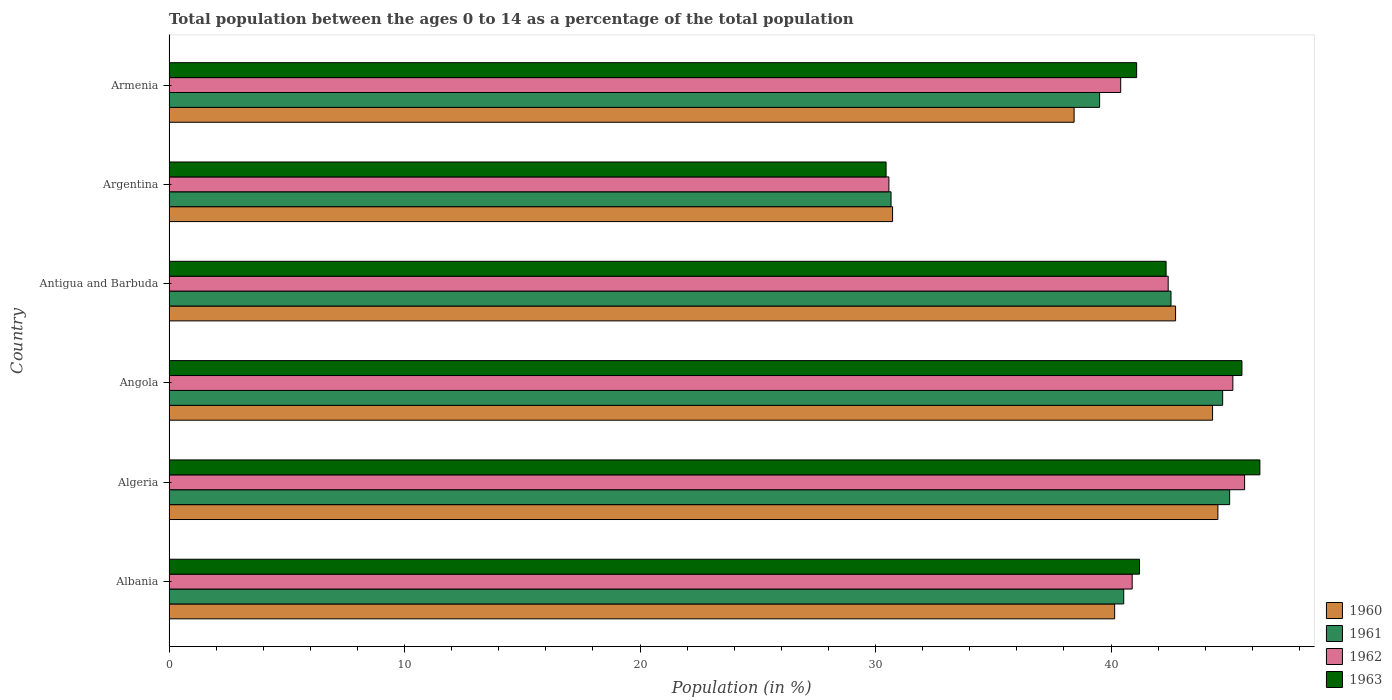How many different coloured bars are there?
Your response must be concise. 4. How many groups of bars are there?
Ensure brevity in your answer.  6. How many bars are there on the 2nd tick from the top?
Make the answer very short. 4. How many bars are there on the 2nd tick from the bottom?
Your response must be concise. 4. What is the label of the 5th group of bars from the top?
Make the answer very short. Algeria. What is the percentage of the population ages 0 to 14 in 1963 in Antigua and Barbuda?
Your answer should be very brief. 42.34. Across all countries, what is the maximum percentage of the population ages 0 to 14 in 1963?
Give a very brief answer. 46.32. Across all countries, what is the minimum percentage of the population ages 0 to 14 in 1960?
Give a very brief answer. 30.73. In which country was the percentage of the population ages 0 to 14 in 1963 maximum?
Provide a short and direct response. Algeria. In which country was the percentage of the population ages 0 to 14 in 1963 minimum?
Provide a succinct answer. Argentina. What is the total percentage of the population ages 0 to 14 in 1961 in the graph?
Offer a terse response. 243.05. What is the difference between the percentage of the population ages 0 to 14 in 1963 in Albania and that in Argentina?
Give a very brief answer. 10.76. What is the difference between the percentage of the population ages 0 to 14 in 1962 in Antigua and Barbuda and the percentage of the population ages 0 to 14 in 1960 in Angola?
Make the answer very short. -1.88. What is the average percentage of the population ages 0 to 14 in 1960 per country?
Provide a short and direct response. 40.15. What is the difference between the percentage of the population ages 0 to 14 in 1962 and percentage of the population ages 0 to 14 in 1961 in Armenia?
Provide a succinct answer. 0.89. What is the ratio of the percentage of the population ages 0 to 14 in 1960 in Antigua and Barbuda to that in Argentina?
Make the answer very short. 1.39. What is the difference between the highest and the second highest percentage of the population ages 0 to 14 in 1960?
Your answer should be very brief. 0.23. What is the difference between the highest and the lowest percentage of the population ages 0 to 14 in 1963?
Your answer should be compact. 15.87. Is it the case that in every country, the sum of the percentage of the population ages 0 to 14 in 1962 and percentage of the population ages 0 to 14 in 1963 is greater than the sum of percentage of the population ages 0 to 14 in 1961 and percentage of the population ages 0 to 14 in 1960?
Offer a terse response. No. What does the 1st bar from the bottom in Armenia represents?
Offer a very short reply. 1960. Is it the case that in every country, the sum of the percentage of the population ages 0 to 14 in 1960 and percentage of the population ages 0 to 14 in 1961 is greater than the percentage of the population ages 0 to 14 in 1963?
Provide a succinct answer. Yes. How many bars are there?
Your answer should be compact. 24. Are all the bars in the graph horizontal?
Your answer should be compact. Yes. What is the difference between two consecutive major ticks on the X-axis?
Provide a succinct answer. 10. Are the values on the major ticks of X-axis written in scientific E-notation?
Offer a very short reply. No. How are the legend labels stacked?
Give a very brief answer. Vertical. What is the title of the graph?
Keep it short and to the point. Total population between the ages 0 to 14 as a percentage of the total population. What is the label or title of the X-axis?
Keep it short and to the point. Population (in %). What is the Population (in %) in 1960 in Albania?
Keep it short and to the point. 40.15. What is the Population (in %) in 1961 in Albania?
Your answer should be very brief. 40.54. What is the Population (in %) in 1962 in Albania?
Your answer should be compact. 40.9. What is the Population (in %) of 1963 in Albania?
Give a very brief answer. 41.21. What is the Population (in %) of 1960 in Algeria?
Your answer should be compact. 44.54. What is the Population (in %) in 1961 in Algeria?
Your answer should be very brief. 45.04. What is the Population (in %) in 1962 in Algeria?
Make the answer very short. 45.67. What is the Population (in %) in 1963 in Algeria?
Make the answer very short. 46.32. What is the Population (in %) of 1960 in Angola?
Your answer should be compact. 44.31. What is the Population (in %) of 1961 in Angola?
Offer a very short reply. 44.74. What is the Population (in %) in 1962 in Angola?
Ensure brevity in your answer.  45.17. What is the Population (in %) of 1963 in Angola?
Offer a very short reply. 45.56. What is the Population (in %) of 1960 in Antigua and Barbuda?
Your answer should be compact. 42.74. What is the Population (in %) of 1961 in Antigua and Barbuda?
Provide a succinct answer. 42.55. What is the Population (in %) of 1962 in Antigua and Barbuda?
Your answer should be very brief. 42.43. What is the Population (in %) in 1963 in Antigua and Barbuda?
Make the answer very short. 42.34. What is the Population (in %) in 1960 in Argentina?
Provide a succinct answer. 30.73. What is the Population (in %) in 1961 in Argentina?
Ensure brevity in your answer.  30.66. What is the Population (in %) of 1962 in Argentina?
Provide a short and direct response. 30.57. What is the Population (in %) of 1963 in Argentina?
Give a very brief answer. 30.45. What is the Population (in %) of 1960 in Armenia?
Provide a succinct answer. 38.43. What is the Population (in %) in 1961 in Armenia?
Provide a succinct answer. 39.52. What is the Population (in %) in 1962 in Armenia?
Make the answer very short. 40.41. What is the Population (in %) in 1963 in Armenia?
Ensure brevity in your answer.  41.09. Across all countries, what is the maximum Population (in %) in 1960?
Offer a terse response. 44.54. Across all countries, what is the maximum Population (in %) of 1961?
Give a very brief answer. 45.04. Across all countries, what is the maximum Population (in %) of 1962?
Ensure brevity in your answer.  45.67. Across all countries, what is the maximum Population (in %) in 1963?
Provide a succinct answer. 46.32. Across all countries, what is the minimum Population (in %) of 1960?
Provide a succinct answer. 30.73. Across all countries, what is the minimum Population (in %) of 1961?
Provide a short and direct response. 30.66. Across all countries, what is the minimum Population (in %) in 1962?
Keep it short and to the point. 30.57. Across all countries, what is the minimum Population (in %) of 1963?
Give a very brief answer. 30.45. What is the total Population (in %) in 1960 in the graph?
Make the answer very short. 240.91. What is the total Population (in %) in 1961 in the graph?
Ensure brevity in your answer.  243.05. What is the total Population (in %) of 1962 in the graph?
Give a very brief answer. 245.16. What is the total Population (in %) in 1963 in the graph?
Give a very brief answer. 246.97. What is the difference between the Population (in %) of 1960 in Albania and that in Algeria?
Your response must be concise. -4.38. What is the difference between the Population (in %) of 1961 in Albania and that in Algeria?
Ensure brevity in your answer.  -4.5. What is the difference between the Population (in %) in 1962 in Albania and that in Algeria?
Ensure brevity in your answer.  -4.77. What is the difference between the Population (in %) of 1963 in Albania and that in Algeria?
Provide a succinct answer. -5.11. What is the difference between the Population (in %) of 1960 in Albania and that in Angola?
Ensure brevity in your answer.  -4.16. What is the difference between the Population (in %) of 1961 in Albania and that in Angola?
Give a very brief answer. -4.2. What is the difference between the Population (in %) of 1962 in Albania and that in Angola?
Offer a very short reply. -4.28. What is the difference between the Population (in %) in 1963 in Albania and that in Angola?
Provide a succinct answer. -4.35. What is the difference between the Population (in %) of 1960 in Albania and that in Antigua and Barbuda?
Keep it short and to the point. -2.59. What is the difference between the Population (in %) in 1961 in Albania and that in Antigua and Barbuda?
Provide a short and direct response. -2.01. What is the difference between the Population (in %) in 1962 in Albania and that in Antigua and Barbuda?
Provide a short and direct response. -1.53. What is the difference between the Population (in %) of 1963 in Albania and that in Antigua and Barbuda?
Make the answer very short. -1.13. What is the difference between the Population (in %) in 1960 in Albania and that in Argentina?
Your answer should be very brief. 9.43. What is the difference between the Population (in %) of 1961 in Albania and that in Argentina?
Provide a succinct answer. 9.88. What is the difference between the Population (in %) of 1962 in Albania and that in Argentina?
Give a very brief answer. 10.33. What is the difference between the Population (in %) in 1963 in Albania and that in Argentina?
Ensure brevity in your answer.  10.76. What is the difference between the Population (in %) in 1960 in Albania and that in Armenia?
Your response must be concise. 1.72. What is the difference between the Population (in %) in 1961 in Albania and that in Armenia?
Provide a short and direct response. 1.02. What is the difference between the Population (in %) in 1962 in Albania and that in Armenia?
Your answer should be compact. 0.49. What is the difference between the Population (in %) in 1963 in Albania and that in Armenia?
Make the answer very short. 0.12. What is the difference between the Population (in %) in 1960 in Algeria and that in Angola?
Give a very brief answer. 0.23. What is the difference between the Population (in %) in 1961 in Algeria and that in Angola?
Your response must be concise. 0.3. What is the difference between the Population (in %) in 1962 in Algeria and that in Angola?
Your response must be concise. 0.5. What is the difference between the Population (in %) in 1963 in Algeria and that in Angola?
Provide a short and direct response. 0.76. What is the difference between the Population (in %) in 1960 in Algeria and that in Antigua and Barbuda?
Keep it short and to the point. 1.8. What is the difference between the Population (in %) of 1961 in Algeria and that in Antigua and Barbuda?
Your answer should be very brief. 2.49. What is the difference between the Population (in %) in 1962 in Algeria and that in Antigua and Barbuda?
Provide a short and direct response. 3.25. What is the difference between the Population (in %) of 1963 in Algeria and that in Antigua and Barbuda?
Offer a very short reply. 3.98. What is the difference between the Population (in %) in 1960 in Algeria and that in Argentina?
Keep it short and to the point. 13.81. What is the difference between the Population (in %) of 1961 in Algeria and that in Argentina?
Make the answer very short. 14.38. What is the difference between the Population (in %) in 1962 in Algeria and that in Argentina?
Make the answer very short. 15.1. What is the difference between the Population (in %) of 1963 in Algeria and that in Argentina?
Your answer should be very brief. 15.87. What is the difference between the Population (in %) of 1960 in Algeria and that in Armenia?
Your answer should be very brief. 6.11. What is the difference between the Population (in %) in 1961 in Algeria and that in Armenia?
Provide a short and direct response. 5.52. What is the difference between the Population (in %) of 1962 in Algeria and that in Armenia?
Offer a very short reply. 5.26. What is the difference between the Population (in %) in 1963 in Algeria and that in Armenia?
Your answer should be very brief. 5.23. What is the difference between the Population (in %) of 1960 in Angola and that in Antigua and Barbuda?
Ensure brevity in your answer.  1.57. What is the difference between the Population (in %) of 1961 in Angola and that in Antigua and Barbuda?
Offer a very short reply. 2.19. What is the difference between the Population (in %) of 1962 in Angola and that in Antigua and Barbuda?
Provide a short and direct response. 2.75. What is the difference between the Population (in %) in 1963 in Angola and that in Antigua and Barbuda?
Offer a very short reply. 3.22. What is the difference between the Population (in %) of 1960 in Angola and that in Argentina?
Offer a terse response. 13.59. What is the difference between the Population (in %) of 1961 in Angola and that in Argentina?
Your answer should be compact. 14.08. What is the difference between the Population (in %) in 1962 in Angola and that in Argentina?
Make the answer very short. 14.61. What is the difference between the Population (in %) of 1963 in Angola and that in Argentina?
Provide a succinct answer. 15.11. What is the difference between the Population (in %) in 1960 in Angola and that in Armenia?
Ensure brevity in your answer.  5.88. What is the difference between the Population (in %) in 1961 in Angola and that in Armenia?
Your response must be concise. 5.22. What is the difference between the Population (in %) of 1962 in Angola and that in Armenia?
Make the answer very short. 4.76. What is the difference between the Population (in %) in 1963 in Angola and that in Armenia?
Give a very brief answer. 4.47. What is the difference between the Population (in %) in 1960 in Antigua and Barbuda and that in Argentina?
Give a very brief answer. 12.02. What is the difference between the Population (in %) of 1961 in Antigua and Barbuda and that in Argentina?
Your answer should be very brief. 11.89. What is the difference between the Population (in %) of 1962 in Antigua and Barbuda and that in Argentina?
Ensure brevity in your answer.  11.86. What is the difference between the Population (in %) in 1963 in Antigua and Barbuda and that in Argentina?
Your response must be concise. 11.89. What is the difference between the Population (in %) of 1960 in Antigua and Barbuda and that in Armenia?
Provide a succinct answer. 4.31. What is the difference between the Population (in %) of 1961 in Antigua and Barbuda and that in Armenia?
Provide a short and direct response. 3.03. What is the difference between the Population (in %) of 1962 in Antigua and Barbuda and that in Armenia?
Keep it short and to the point. 2.02. What is the difference between the Population (in %) of 1963 in Antigua and Barbuda and that in Armenia?
Your response must be concise. 1.25. What is the difference between the Population (in %) in 1960 in Argentina and that in Armenia?
Provide a succinct answer. -7.71. What is the difference between the Population (in %) in 1961 in Argentina and that in Armenia?
Offer a terse response. -8.86. What is the difference between the Population (in %) of 1962 in Argentina and that in Armenia?
Offer a very short reply. -9.84. What is the difference between the Population (in %) in 1963 in Argentina and that in Armenia?
Make the answer very short. -10.64. What is the difference between the Population (in %) in 1960 in Albania and the Population (in %) in 1961 in Algeria?
Ensure brevity in your answer.  -4.88. What is the difference between the Population (in %) of 1960 in Albania and the Population (in %) of 1962 in Algeria?
Your response must be concise. -5.52. What is the difference between the Population (in %) in 1960 in Albania and the Population (in %) in 1963 in Algeria?
Your answer should be very brief. -6.17. What is the difference between the Population (in %) in 1961 in Albania and the Population (in %) in 1962 in Algeria?
Offer a terse response. -5.13. What is the difference between the Population (in %) in 1961 in Albania and the Population (in %) in 1963 in Algeria?
Provide a short and direct response. -5.78. What is the difference between the Population (in %) in 1962 in Albania and the Population (in %) in 1963 in Algeria?
Offer a very short reply. -5.42. What is the difference between the Population (in %) of 1960 in Albania and the Population (in %) of 1961 in Angola?
Ensure brevity in your answer.  -4.59. What is the difference between the Population (in %) of 1960 in Albania and the Population (in %) of 1962 in Angola?
Offer a very short reply. -5.02. What is the difference between the Population (in %) in 1960 in Albania and the Population (in %) in 1963 in Angola?
Ensure brevity in your answer.  -5.41. What is the difference between the Population (in %) in 1961 in Albania and the Population (in %) in 1962 in Angola?
Keep it short and to the point. -4.63. What is the difference between the Population (in %) in 1961 in Albania and the Population (in %) in 1963 in Angola?
Keep it short and to the point. -5.02. What is the difference between the Population (in %) in 1962 in Albania and the Population (in %) in 1963 in Angola?
Offer a very short reply. -4.66. What is the difference between the Population (in %) in 1960 in Albania and the Population (in %) in 1961 in Antigua and Barbuda?
Offer a terse response. -2.39. What is the difference between the Population (in %) of 1960 in Albania and the Population (in %) of 1962 in Antigua and Barbuda?
Your answer should be compact. -2.27. What is the difference between the Population (in %) in 1960 in Albania and the Population (in %) in 1963 in Antigua and Barbuda?
Provide a short and direct response. -2.18. What is the difference between the Population (in %) in 1961 in Albania and the Population (in %) in 1962 in Antigua and Barbuda?
Your response must be concise. -1.89. What is the difference between the Population (in %) in 1961 in Albania and the Population (in %) in 1963 in Antigua and Barbuda?
Provide a short and direct response. -1.8. What is the difference between the Population (in %) of 1962 in Albania and the Population (in %) of 1963 in Antigua and Barbuda?
Give a very brief answer. -1.44. What is the difference between the Population (in %) of 1960 in Albania and the Population (in %) of 1961 in Argentina?
Provide a short and direct response. 9.49. What is the difference between the Population (in %) of 1960 in Albania and the Population (in %) of 1962 in Argentina?
Ensure brevity in your answer.  9.59. What is the difference between the Population (in %) in 1960 in Albania and the Population (in %) in 1963 in Argentina?
Offer a terse response. 9.71. What is the difference between the Population (in %) of 1961 in Albania and the Population (in %) of 1962 in Argentina?
Your response must be concise. 9.97. What is the difference between the Population (in %) of 1961 in Albania and the Population (in %) of 1963 in Argentina?
Give a very brief answer. 10.09. What is the difference between the Population (in %) in 1962 in Albania and the Population (in %) in 1963 in Argentina?
Provide a succinct answer. 10.45. What is the difference between the Population (in %) of 1960 in Albania and the Population (in %) of 1961 in Armenia?
Provide a short and direct response. 0.64. What is the difference between the Population (in %) in 1960 in Albania and the Population (in %) in 1962 in Armenia?
Provide a succinct answer. -0.26. What is the difference between the Population (in %) of 1960 in Albania and the Population (in %) of 1963 in Armenia?
Make the answer very short. -0.93. What is the difference between the Population (in %) in 1961 in Albania and the Population (in %) in 1962 in Armenia?
Your answer should be very brief. 0.13. What is the difference between the Population (in %) of 1961 in Albania and the Population (in %) of 1963 in Armenia?
Your answer should be compact. -0.55. What is the difference between the Population (in %) of 1962 in Albania and the Population (in %) of 1963 in Armenia?
Your answer should be compact. -0.19. What is the difference between the Population (in %) of 1960 in Algeria and the Population (in %) of 1961 in Angola?
Your answer should be compact. -0.2. What is the difference between the Population (in %) of 1960 in Algeria and the Population (in %) of 1962 in Angola?
Ensure brevity in your answer.  -0.64. What is the difference between the Population (in %) of 1960 in Algeria and the Population (in %) of 1963 in Angola?
Offer a very short reply. -1.02. What is the difference between the Population (in %) in 1961 in Algeria and the Population (in %) in 1962 in Angola?
Your answer should be very brief. -0.14. What is the difference between the Population (in %) of 1961 in Algeria and the Population (in %) of 1963 in Angola?
Your answer should be very brief. -0.52. What is the difference between the Population (in %) in 1962 in Algeria and the Population (in %) in 1963 in Angola?
Provide a succinct answer. 0.11. What is the difference between the Population (in %) of 1960 in Algeria and the Population (in %) of 1961 in Antigua and Barbuda?
Provide a succinct answer. 1.99. What is the difference between the Population (in %) of 1960 in Algeria and the Population (in %) of 1962 in Antigua and Barbuda?
Offer a very short reply. 2.11. What is the difference between the Population (in %) of 1960 in Algeria and the Population (in %) of 1963 in Antigua and Barbuda?
Offer a very short reply. 2.2. What is the difference between the Population (in %) in 1961 in Algeria and the Population (in %) in 1962 in Antigua and Barbuda?
Make the answer very short. 2.61. What is the difference between the Population (in %) in 1961 in Algeria and the Population (in %) in 1963 in Antigua and Barbuda?
Your answer should be very brief. 2.7. What is the difference between the Population (in %) in 1962 in Algeria and the Population (in %) in 1963 in Antigua and Barbuda?
Provide a short and direct response. 3.33. What is the difference between the Population (in %) in 1960 in Algeria and the Population (in %) in 1961 in Argentina?
Give a very brief answer. 13.88. What is the difference between the Population (in %) of 1960 in Algeria and the Population (in %) of 1962 in Argentina?
Offer a very short reply. 13.97. What is the difference between the Population (in %) of 1960 in Algeria and the Population (in %) of 1963 in Argentina?
Provide a succinct answer. 14.09. What is the difference between the Population (in %) in 1961 in Algeria and the Population (in %) in 1962 in Argentina?
Your answer should be very brief. 14.47. What is the difference between the Population (in %) in 1961 in Algeria and the Population (in %) in 1963 in Argentina?
Your answer should be compact. 14.59. What is the difference between the Population (in %) of 1962 in Algeria and the Population (in %) of 1963 in Argentina?
Make the answer very short. 15.22. What is the difference between the Population (in %) in 1960 in Algeria and the Population (in %) in 1961 in Armenia?
Your answer should be very brief. 5.02. What is the difference between the Population (in %) of 1960 in Algeria and the Population (in %) of 1962 in Armenia?
Make the answer very short. 4.13. What is the difference between the Population (in %) in 1960 in Algeria and the Population (in %) in 1963 in Armenia?
Offer a very short reply. 3.45. What is the difference between the Population (in %) of 1961 in Algeria and the Population (in %) of 1962 in Armenia?
Offer a very short reply. 4.63. What is the difference between the Population (in %) of 1961 in Algeria and the Population (in %) of 1963 in Armenia?
Provide a succinct answer. 3.95. What is the difference between the Population (in %) in 1962 in Algeria and the Population (in %) in 1963 in Armenia?
Make the answer very short. 4.58. What is the difference between the Population (in %) of 1960 in Angola and the Population (in %) of 1961 in Antigua and Barbuda?
Make the answer very short. 1.76. What is the difference between the Population (in %) of 1960 in Angola and the Population (in %) of 1962 in Antigua and Barbuda?
Your answer should be very brief. 1.88. What is the difference between the Population (in %) in 1960 in Angola and the Population (in %) in 1963 in Antigua and Barbuda?
Ensure brevity in your answer.  1.97. What is the difference between the Population (in %) of 1961 in Angola and the Population (in %) of 1962 in Antigua and Barbuda?
Provide a succinct answer. 2.31. What is the difference between the Population (in %) of 1961 in Angola and the Population (in %) of 1963 in Antigua and Barbuda?
Give a very brief answer. 2.4. What is the difference between the Population (in %) in 1962 in Angola and the Population (in %) in 1963 in Antigua and Barbuda?
Your response must be concise. 2.84. What is the difference between the Population (in %) in 1960 in Angola and the Population (in %) in 1961 in Argentina?
Make the answer very short. 13.65. What is the difference between the Population (in %) in 1960 in Angola and the Population (in %) in 1962 in Argentina?
Offer a terse response. 13.74. What is the difference between the Population (in %) in 1960 in Angola and the Population (in %) in 1963 in Argentina?
Keep it short and to the point. 13.86. What is the difference between the Population (in %) in 1961 in Angola and the Population (in %) in 1962 in Argentina?
Provide a short and direct response. 14.17. What is the difference between the Population (in %) in 1961 in Angola and the Population (in %) in 1963 in Argentina?
Your answer should be compact. 14.29. What is the difference between the Population (in %) in 1962 in Angola and the Population (in %) in 1963 in Argentina?
Provide a short and direct response. 14.73. What is the difference between the Population (in %) in 1960 in Angola and the Population (in %) in 1961 in Armenia?
Your response must be concise. 4.8. What is the difference between the Population (in %) in 1960 in Angola and the Population (in %) in 1962 in Armenia?
Ensure brevity in your answer.  3.9. What is the difference between the Population (in %) in 1960 in Angola and the Population (in %) in 1963 in Armenia?
Offer a very short reply. 3.22. What is the difference between the Population (in %) in 1961 in Angola and the Population (in %) in 1962 in Armenia?
Ensure brevity in your answer.  4.33. What is the difference between the Population (in %) in 1961 in Angola and the Population (in %) in 1963 in Armenia?
Your answer should be very brief. 3.65. What is the difference between the Population (in %) of 1962 in Angola and the Population (in %) of 1963 in Armenia?
Your answer should be very brief. 4.09. What is the difference between the Population (in %) in 1960 in Antigua and Barbuda and the Population (in %) in 1961 in Argentina?
Offer a very short reply. 12.08. What is the difference between the Population (in %) of 1960 in Antigua and Barbuda and the Population (in %) of 1962 in Argentina?
Make the answer very short. 12.17. What is the difference between the Population (in %) in 1960 in Antigua and Barbuda and the Population (in %) in 1963 in Argentina?
Your answer should be very brief. 12.29. What is the difference between the Population (in %) in 1961 in Antigua and Barbuda and the Population (in %) in 1962 in Argentina?
Your response must be concise. 11.98. What is the difference between the Population (in %) of 1961 in Antigua and Barbuda and the Population (in %) of 1963 in Argentina?
Make the answer very short. 12.1. What is the difference between the Population (in %) of 1962 in Antigua and Barbuda and the Population (in %) of 1963 in Argentina?
Offer a terse response. 11.98. What is the difference between the Population (in %) of 1960 in Antigua and Barbuda and the Population (in %) of 1961 in Armenia?
Your answer should be compact. 3.23. What is the difference between the Population (in %) of 1960 in Antigua and Barbuda and the Population (in %) of 1962 in Armenia?
Offer a terse response. 2.33. What is the difference between the Population (in %) in 1960 in Antigua and Barbuda and the Population (in %) in 1963 in Armenia?
Make the answer very short. 1.65. What is the difference between the Population (in %) in 1961 in Antigua and Barbuda and the Population (in %) in 1962 in Armenia?
Give a very brief answer. 2.14. What is the difference between the Population (in %) of 1961 in Antigua and Barbuda and the Population (in %) of 1963 in Armenia?
Provide a succinct answer. 1.46. What is the difference between the Population (in %) in 1962 in Antigua and Barbuda and the Population (in %) in 1963 in Armenia?
Offer a very short reply. 1.34. What is the difference between the Population (in %) in 1960 in Argentina and the Population (in %) in 1961 in Armenia?
Provide a short and direct response. -8.79. What is the difference between the Population (in %) in 1960 in Argentina and the Population (in %) in 1962 in Armenia?
Your answer should be compact. -9.69. What is the difference between the Population (in %) of 1960 in Argentina and the Population (in %) of 1963 in Armenia?
Keep it short and to the point. -10.36. What is the difference between the Population (in %) of 1961 in Argentina and the Population (in %) of 1962 in Armenia?
Provide a succinct answer. -9.75. What is the difference between the Population (in %) in 1961 in Argentina and the Population (in %) in 1963 in Armenia?
Make the answer very short. -10.43. What is the difference between the Population (in %) in 1962 in Argentina and the Population (in %) in 1963 in Armenia?
Provide a short and direct response. -10.52. What is the average Population (in %) in 1960 per country?
Make the answer very short. 40.15. What is the average Population (in %) of 1961 per country?
Offer a terse response. 40.51. What is the average Population (in %) in 1962 per country?
Give a very brief answer. 40.86. What is the average Population (in %) in 1963 per country?
Provide a short and direct response. 41.16. What is the difference between the Population (in %) in 1960 and Population (in %) in 1961 in Albania?
Provide a succinct answer. -0.39. What is the difference between the Population (in %) in 1960 and Population (in %) in 1962 in Albania?
Make the answer very short. -0.74. What is the difference between the Population (in %) in 1960 and Population (in %) in 1963 in Albania?
Provide a succinct answer. -1.06. What is the difference between the Population (in %) of 1961 and Population (in %) of 1962 in Albania?
Ensure brevity in your answer.  -0.36. What is the difference between the Population (in %) in 1961 and Population (in %) in 1963 in Albania?
Provide a succinct answer. -0.67. What is the difference between the Population (in %) in 1962 and Population (in %) in 1963 in Albania?
Keep it short and to the point. -0.31. What is the difference between the Population (in %) in 1960 and Population (in %) in 1961 in Algeria?
Offer a very short reply. -0.5. What is the difference between the Population (in %) of 1960 and Population (in %) of 1962 in Algeria?
Provide a short and direct response. -1.13. What is the difference between the Population (in %) of 1960 and Population (in %) of 1963 in Algeria?
Ensure brevity in your answer.  -1.78. What is the difference between the Population (in %) in 1961 and Population (in %) in 1962 in Algeria?
Provide a succinct answer. -0.64. What is the difference between the Population (in %) of 1961 and Population (in %) of 1963 in Algeria?
Your answer should be very brief. -1.28. What is the difference between the Population (in %) of 1962 and Population (in %) of 1963 in Algeria?
Ensure brevity in your answer.  -0.65. What is the difference between the Population (in %) of 1960 and Population (in %) of 1961 in Angola?
Your answer should be compact. -0.43. What is the difference between the Population (in %) in 1960 and Population (in %) in 1962 in Angola?
Ensure brevity in your answer.  -0.86. What is the difference between the Population (in %) in 1960 and Population (in %) in 1963 in Angola?
Make the answer very short. -1.25. What is the difference between the Population (in %) in 1961 and Population (in %) in 1962 in Angola?
Keep it short and to the point. -0.43. What is the difference between the Population (in %) in 1961 and Population (in %) in 1963 in Angola?
Provide a succinct answer. -0.82. What is the difference between the Population (in %) in 1962 and Population (in %) in 1963 in Angola?
Your response must be concise. -0.39. What is the difference between the Population (in %) in 1960 and Population (in %) in 1961 in Antigua and Barbuda?
Your answer should be very brief. 0.19. What is the difference between the Population (in %) in 1960 and Population (in %) in 1962 in Antigua and Barbuda?
Provide a succinct answer. 0.31. What is the difference between the Population (in %) in 1960 and Population (in %) in 1963 in Antigua and Barbuda?
Offer a very short reply. 0.4. What is the difference between the Population (in %) in 1961 and Population (in %) in 1962 in Antigua and Barbuda?
Your answer should be very brief. 0.12. What is the difference between the Population (in %) in 1961 and Population (in %) in 1963 in Antigua and Barbuda?
Provide a succinct answer. 0.21. What is the difference between the Population (in %) in 1962 and Population (in %) in 1963 in Antigua and Barbuda?
Offer a terse response. 0.09. What is the difference between the Population (in %) in 1960 and Population (in %) in 1961 in Argentina?
Provide a short and direct response. 0.07. What is the difference between the Population (in %) in 1960 and Population (in %) in 1962 in Argentina?
Provide a succinct answer. 0.16. What is the difference between the Population (in %) of 1960 and Population (in %) of 1963 in Argentina?
Ensure brevity in your answer.  0.28. What is the difference between the Population (in %) of 1961 and Population (in %) of 1962 in Argentina?
Provide a succinct answer. 0.09. What is the difference between the Population (in %) of 1961 and Population (in %) of 1963 in Argentina?
Offer a very short reply. 0.21. What is the difference between the Population (in %) in 1962 and Population (in %) in 1963 in Argentina?
Provide a short and direct response. 0.12. What is the difference between the Population (in %) of 1960 and Population (in %) of 1961 in Armenia?
Your answer should be very brief. -1.08. What is the difference between the Population (in %) of 1960 and Population (in %) of 1962 in Armenia?
Your response must be concise. -1.98. What is the difference between the Population (in %) of 1960 and Population (in %) of 1963 in Armenia?
Your answer should be compact. -2.66. What is the difference between the Population (in %) in 1961 and Population (in %) in 1962 in Armenia?
Your answer should be very brief. -0.89. What is the difference between the Population (in %) in 1961 and Population (in %) in 1963 in Armenia?
Offer a very short reply. -1.57. What is the difference between the Population (in %) of 1962 and Population (in %) of 1963 in Armenia?
Give a very brief answer. -0.68. What is the ratio of the Population (in %) in 1960 in Albania to that in Algeria?
Ensure brevity in your answer.  0.9. What is the ratio of the Population (in %) of 1961 in Albania to that in Algeria?
Your response must be concise. 0.9. What is the ratio of the Population (in %) in 1962 in Albania to that in Algeria?
Provide a short and direct response. 0.9. What is the ratio of the Population (in %) of 1963 in Albania to that in Algeria?
Give a very brief answer. 0.89. What is the ratio of the Population (in %) in 1960 in Albania to that in Angola?
Make the answer very short. 0.91. What is the ratio of the Population (in %) of 1961 in Albania to that in Angola?
Your response must be concise. 0.91. What is the ratio of the Population (in %) of 1962 in Albania to that in Angola?
Provide a short and direct response. 0.91. What is the ratio of the Population (in %) of 1963 in Albania to that in Angola?
Give a very brief answer. 0.9. What is the ratio of the Population (in %) of 1960 in Albania to that in Antigua and Barbuda?
Your answer should be compact. 0.94. What is the ratio of the Population (in %) in 1961 in Albania to that in Antigua and Barbuda?
Provide a short and direct response. 0.95. What is the ratio of the Population (in %) in 1962 in Albania to that in Antigua and Barbuda?
Offer a terse response. 0.96. What is the ratio of the Population (in %) of 1963 in Albania to that in Antigua and Barbuda?
Give a very brief answer. 0.97. What is the ratio of the Population (in %) in 1960 in Albania to that in Argentina?
Offer a very short reply. 1.31. What is the ratio of the Population (in %) of 1961 in Albania to that in Argentina?
Your response must be concise. 1.32. What is the ratio of the Population (in %) of 1962 in Albania to that in Argentina?
Keep it short and to the point. 1.34. What is the ratio of the Population (in %) in 1963 in Albania to that in Argentina?
Offer a very short reply. 1.35. What is the ratio of the Population (in %) of 1960 in Albania to that in Armenia?
Offer a terse response. 1.04. What is the ratio of the Population (in %) of 1961 in Albania to that in Armenia?
Your answer should be very brief. 1.03. What is the ratio of the Population (in %) in 1962 in Albania to that in Armenia?
Keep it short and to the point. 1.01. What is the ratio of the Population (in %) in 1963 in Albania to that in Armenia?
Provide a short and direct response. 1. What is the ratio of the Population (in %) of 1960 in Algeria to that in Angola?
Provide a short and direct response. 1.01. What is the ratio of the Population (in %) of 1961 in Algeria to that in Angola?
Offer a very short reply. 1.01. What is the ratio of the Population (in %) in 1963 in Algeria to that in Angola?
Make the answer very short. 1.02. What is the ratio of the Population (in %) of 1960 in Algeria to that in Antigua and Barbuda?
Provide a short and direct response. 1.04. What is the ratio of the Population (in %) in 1961 in Algeria to that in Antigua and Barbuda?
Offer a very short reply. 1.06. What is the ratio of the Population (in %) in 1962 in Algeria to that in Antigua and Barbuda?
Your response must be concise. 1.08. What is the ratio of the Population (in %) in 1963 in Algeria to that in Antigua and Barbuda?
Make the answer very short. 1.09. What is the ratio of the Population (in %) of 1960 in Algeria to that in Argentina?
Provide a succinct answer. 1.45. What is the ratio of the Population (in %) of 1961 in Algeria to that in Argentina?
Ensure brevity in your answer.  1.47. What is the ratio of the Population (in %) in 1962 in Algeria to that in Argentina?
Provide a short and direct response. 1.49. What is the ratio of the Population (in %) of 1963 in Algeria to that in Argentina?
Offer a very short reply. 1.52. What is the ratio of the Population (in %) in 1960 in Algeria to that in Armenia?
Keep it short and to the point. 1.16. What is the ratio of the Population (in %) in 1961 in Algeria to that in Armenia?
Give a very brief answer. 1.14. What is the ratio of the Population (in %) of 1962 in Algeria to that in Armenia?
Your answer should be very brief. 1.13. What is the ratio of the Population (in %) of 1963 in Algeria to that in Armenia?
Provide a succinct answer. 1.13. What is the ratio of the Population (in %) of 1960 in Angola to that in Antigua and Barbuda?
Give a very brief answer. 1.04. What is the ratio of the Population (in %) in 1961 in Angola to that in Antigua and Barbuda?
Keep it short and to the point. 1.05. What is the ratio of the Population (in %) in 1962 in Angola to that in Antigua and Barbuda?
Provide a short and direct response. 1.06. What is the ratio of the Population (in %) in 1963 in Angola to that in Antigua and Barbuda?
Ensure brevity in your answer.  1.08. What is the ratio of the Population (in %) in 1960 in Angola to that in Argentina?
Offer a very short reply. 1.44. What is the ratio of the Population (in %) of 1961 in Angola to that in Argentina?
Your response must be concise. 1.46. What is the ratio of the Population (in %) of 1962 in Angola to that in Argentina?
Your answer should be very brief. 1.48. What is the ratio of the Population (in %) of 1963 in Angola to that in Argentina?
Provide a short and direct response. 1.5. What is the ratio of the Population (in %) in 1960 in Angola to that in Armenia?
Keep it short and to the point. 1.15. What is the ratio of the Population (in %) in 1961 in Angola to that in Armenia?
Offer a terse response. 1.13. What is the ratio of the Population (in %) in 1962 in Angola to that in Armenia?
Provide a succinct answer. 1.12. What is the ratio of the Population (in %) of 1963 in Angola to that in Armenia?
Offer a very short reply. 1.11. What is the ratio of the Population (in %) in 1960 in Antigua and Barbuda to that in Argentina?
Keep it short and to the point. 1.39. What is the ratio of the Population (in %) of 1961 in Antigua and Barbuda to that in Argentina?
Give a very brief answer. 1.39. What is the ratio of the Population (in %) in 1962 in Antigua and Barbuda to that in Argentina?
Make the answer very short. 1.39. What is the ratio of the Population (in %) in 1963 in Antigua and Barbuda to that in Argentina?
Make the answer very short. 1.39. What is the ratio of the Population (in %) of 1960 in Antigua and Barbuda to that in Armenia?
Give a very brief answer. 1.11. What is the ratio of the Population (in %) of 1961 in Antigua and Barbuda to that in Armenia?
Provide a succinct answer. 1.08. What is the ratio of the Population (in %) in 1962 in Antigua and Barbuda to that in Armenia?
Offer a terse response. 1.05. What is the ratio of the Population (in %) in 1963 in Antigua and Barbuda to that in Armenia?
Give a very brief answer. 1.03. What is the ratio of the Population (in %) of 1960 in Argentina to that in Armenia?
Your answer should be compact. 0.8. What is the ratio of the Population (in %) of 1961 in Argentina to that in Armenia?
Ensure brevity in your answer.  0.78. What is the ratio of the Population (in %) in 1962 in Argentina to that in Armenia?
Keep it short and to the point. 0.76. What is the ratio of the Population (in %) in 1963 in Argentina to that in Armenia?
Your answer should be compact. 0.74. What is the difference between the highest and the second highest Population (in %) in 1960?
Your answer should be very brief. 0.23. What is the difference between the highest and the second highest Population (in %) of 1961?
Provide a succinct answer. 0.3. What is the difference between the highest and the second highest Population (in %) of 1962?
Offer a very short reply. 0.5. What is the difference between the highest and the second highest Population (in %) in 1963?
Your answer should be compact. 0.76. What is the difference between the highest and the lowest Population (in %) of 1960?
Keep it short and to the point. 13.81. What is the difference between the highest and the lowest Population (in %) of 1961?
Ensure brevity in your answer.  14.38. What is the difference between the highest and the lowest Population (in %) in 1962?
Your answer should be very brief. 15.1. What is the difference between the highest and the lowest Population (in %) in 1963?
Ensure brevity in your answer.  15.87. 